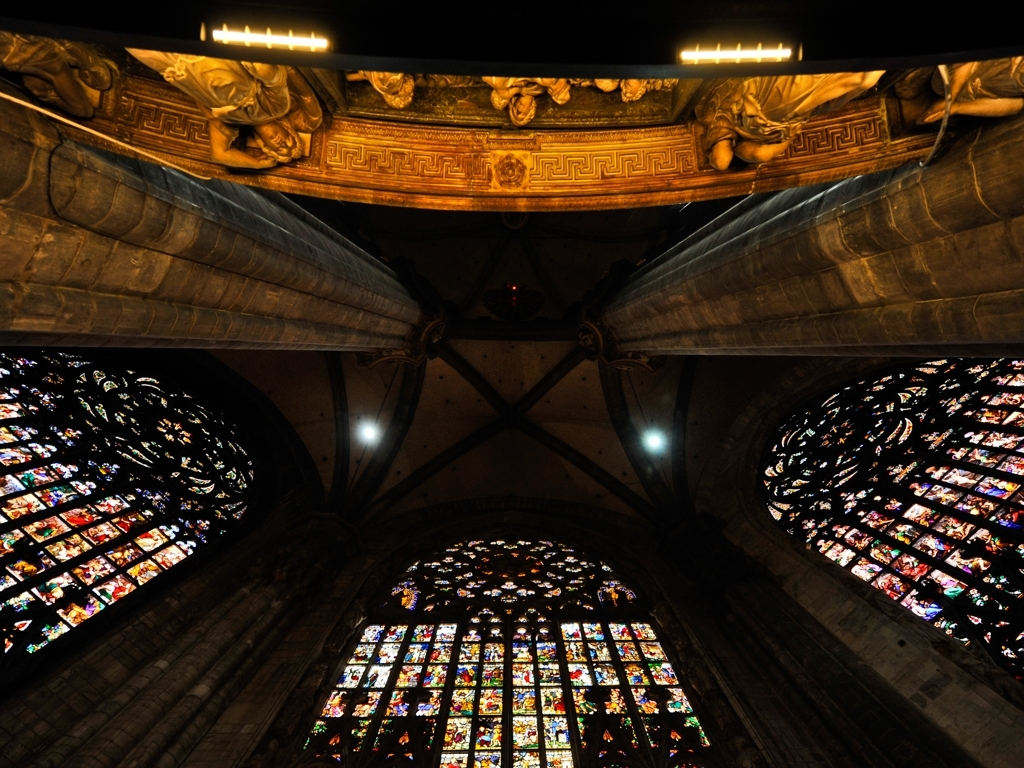Are there any distortions in the image?
A. Yes
B. No
Answer with the option's letter from the given choices directly.
 B. 